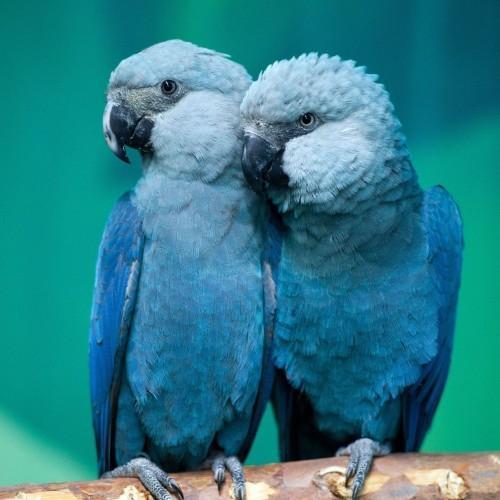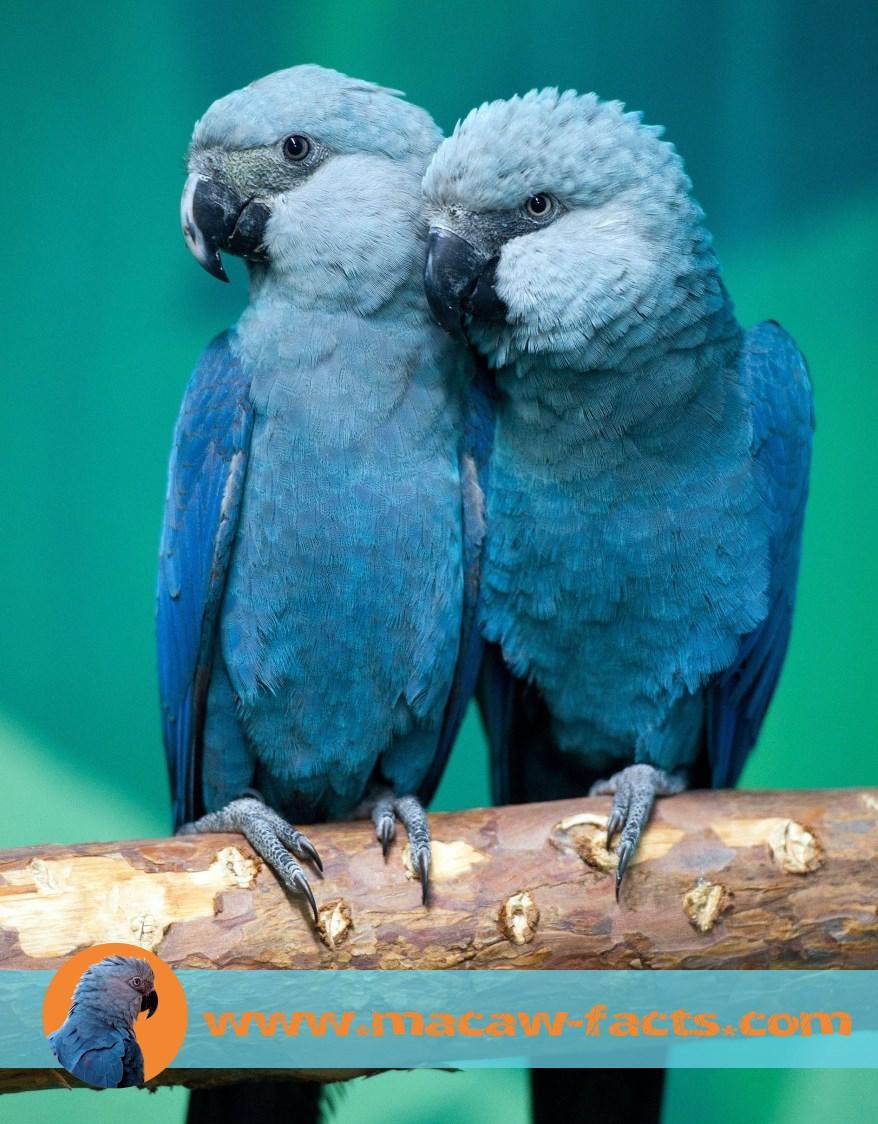The first image is the image on the left, the second image is the image on the right. Evaluate the accuracy of this statement regarding the images: "All of the birds sit on a branch with a blue background behind them.". Is it true? Answer yes or no. Yes. 